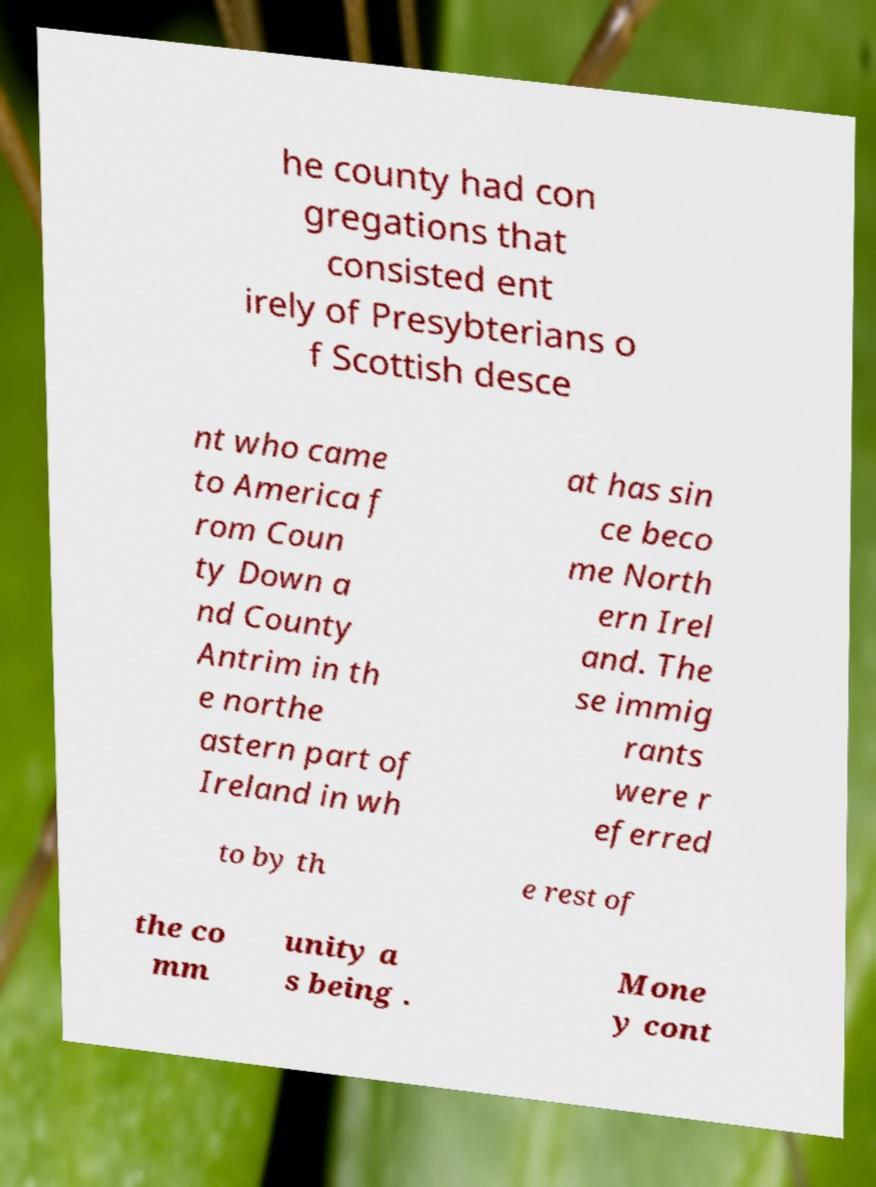Could you extract and type out the text from this image? he county had con gregations that consisted ent irely of Presybterians o f Scottish desce nt who came to America f rom Coun ty Down a nd County Antrim in th e northe astern part of Ireland in wh at has sin ce beco me North ern Irel and. The se immig rants were r eferred to by th e rest of the co mm unity a s being . Mone y cont 